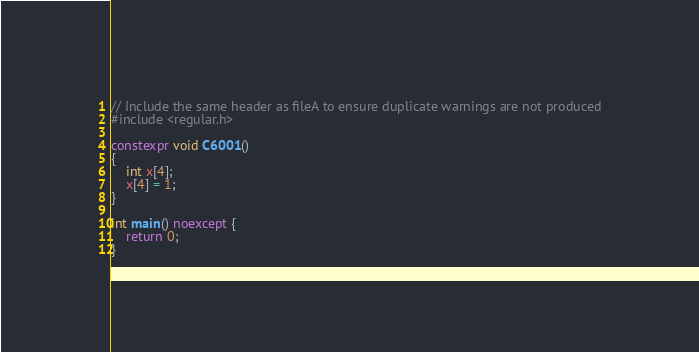<code> <loc_0><loc_0><loc_500><loc_500><_C++_>// Include the same header as fileA to ensure duplicate warnings are not produced
#include <regular.h>

constexpr void C6001()
{
    int x[4];
    x[4] = 1;
}

int main() noexcept {
    return 0;
}
</code> 